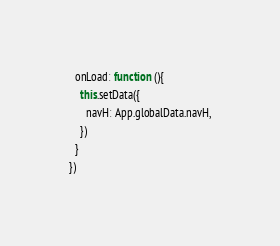<code> <loc_0><loc_0><loc_500><loc_500><_JavaScript_>  onLoad: function (){
    this.setData({
      navH: App.globalData.navH,
    })
  }
})</code> 